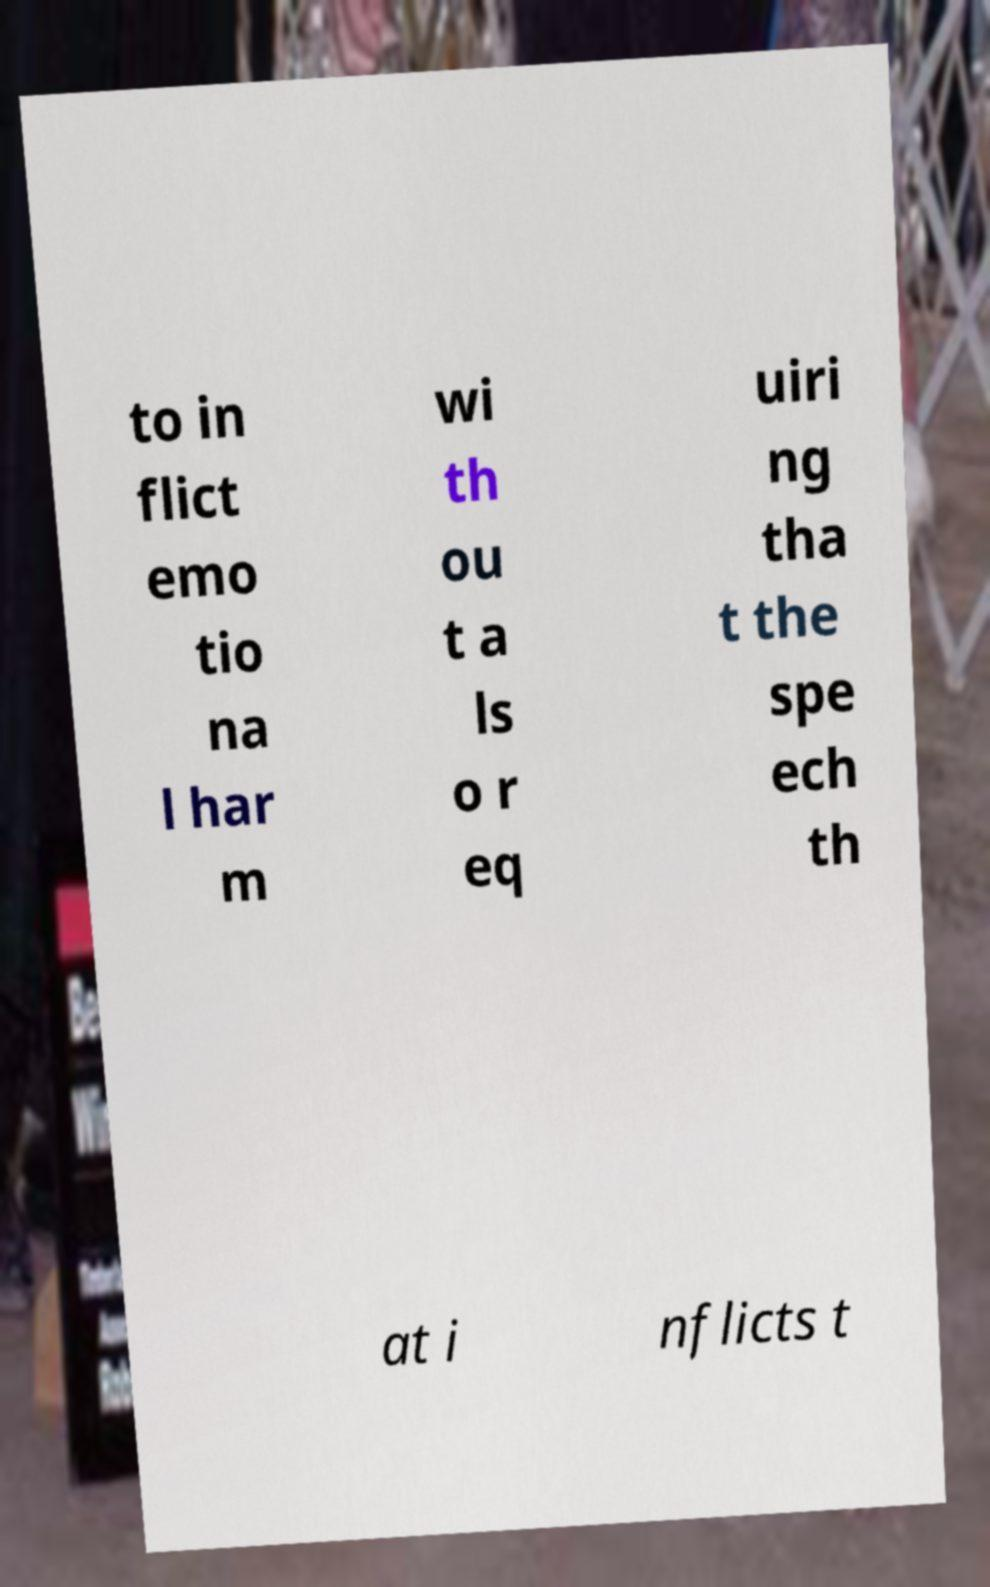Please read and relay the text visible in this image. What does it say? to in flict emo tio na l har m wi th ou t a ls o r eq uiri ng tha t the spe ech th at i nflicts t 